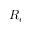<formula> <loc_0><loc_0><loc_500><loc_500>R _ { e }</formula> 